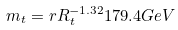<formula> <loc_0><loc_0><loc_500><loc_500>m _ { t } = r R ^ { - 1 . 3 2 } _ { t } 1 7 9 . 4 G e V</formula> 